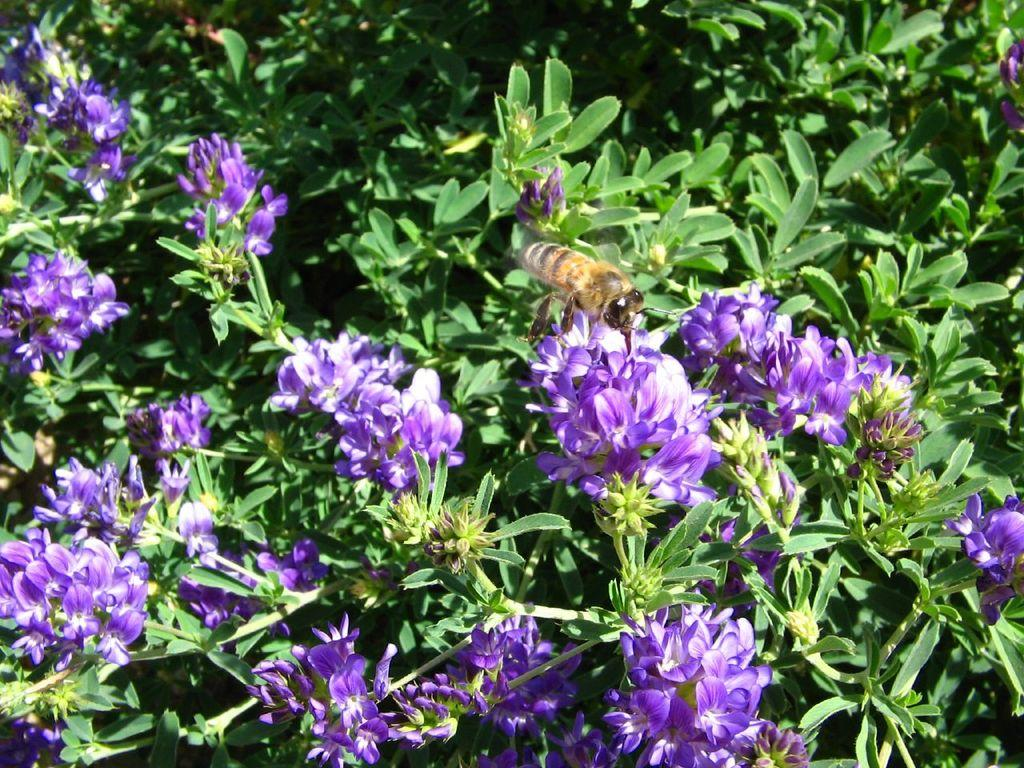What is on the flower in the image? There is a honey bee on a flower in the image. What type of vegetation can be seen in the image? There are plants and flowers visible in the image. What type of trouble is the honey bee causing in the image? There is no indication of trouble in the image; the honey bee is simply on a flower. 